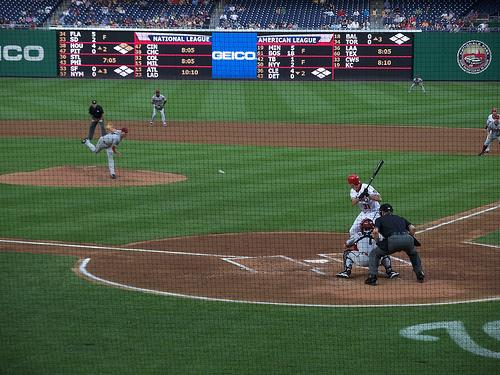Name three elements you can observe in the image related to baseball equipment or clothing. A baseball in the air, a baseball player wearing a red helmet, and a man holding a baseball bat. Can you spot any information about the league that the game is being played in? Yes, there are stats for both the National and American leagues displayed on the scoreboard. What is happening in the central part of the image related to baseball? A baseball pitcher is throwing a baseball, while a player with a black bat and a red helmet is getting ready to swing. What is the central focus of this image in terms of sports? The central focus of this image is a baseball game in progress. What type of field are the players playing on in this image? The players are playing on a baseball field. Identify the color and content of the sign in the image. The sign is blue and has the Geico logo in white lettering. In which part of the stadium is the Geico advertisement located? The Geico advertisement is located on the scoreboard. 